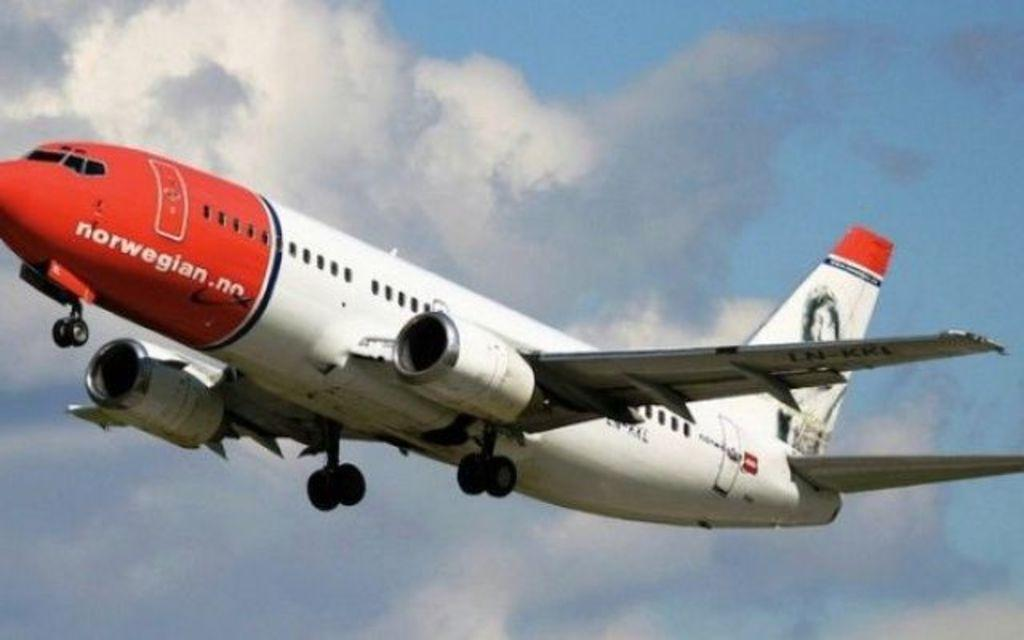<image>
Create a compact narrative representing the image presented. A red and white plane has Norwegian written on the nose. 